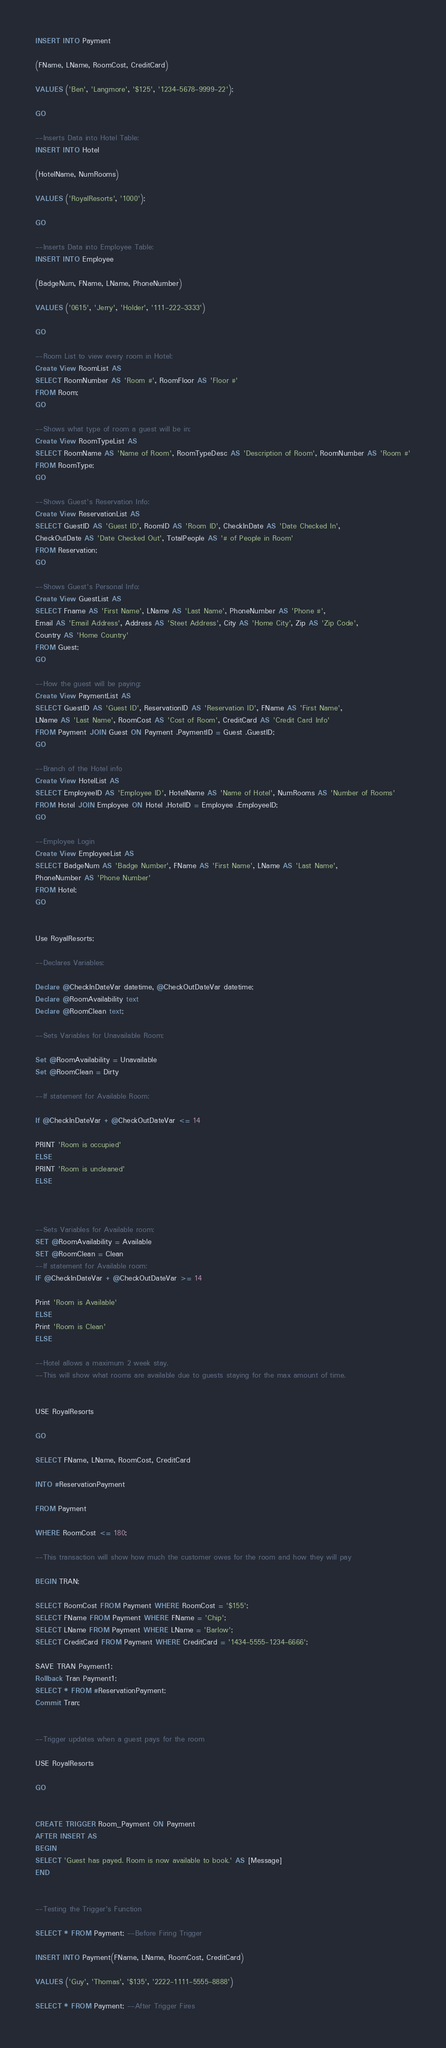Convert code to text. <code><loc_0><loc_0><loc_500><loc_500><_SQL_>INSERT INTO Payment

(FName, LName, RoomCost, CreditCard)

VALUES ('Ben', 'Langmore', '$125', '1234-5678-9999-22');

GO

--Inserts Data into Hotel Table:
INSERT INTO Hotel

(HotelName, NumRooms)

VALUES ('RoyalResorts', '1000');

GO

--Inserts Data into Employee Table:
INSERT INTO Employee

(BadgeNum, FName, LName, PhoneNumber)

VALUES ('0615', 'Jerry', 'Holder', '111-222-3333')

GO

--Room List to view every room in Hotel:
Create View RoomList AS
SELECT RoomNumber AS 'Room #', RoomFloor AS 'Floor #'
FROM Room;
GO

--Shows what type of room a guest will be in:
Create View RoomTypeList AS
SELECT RoomName AS 'Name of Room', RoomTypeDesc AS 'Description of Room', RoomNumber AS 'Room #'
FROM RoomType;
GO

--Shows Guest's Reservation Info:
Create View ReservationList AS
SELECT GuestID AS 'Guest ID', RoomID AS 'Room ID', CheckInDate AS 'Date Checked In',
CheckOutDate AS 'Date Checked Out', TotalPeople AS '# of People in Room'
FROM Reservation;
GO

--Shows Guest's Personal Info:
Create View GuestList AS
SELECT Fname AS 'First Name', LName AS 'Last Name', PhoneNumber AS 'Phone #',
Email AS 'Email Address', Address AS 'Steet Address', City AS 'Home City', Zip AS 'Zip Code',
Country AS 'Home Country'
FROM Guest;
GO

--How the guest will be paying:
Create View PaymentList AS
SELECT GuestID AS 'Guest ID', ReservationID AS 'Reservation ID', FName AS 'First Name',
LName AS 'Last Name', RoomCost AS 'Cost of Room', CreditCard AS 'Credit Card Info'
FROM Payment JOIN Guest ON Payment .PaymentID = Guest .GuestID;
GO

--Branch of the Hotel info
Create View HotelList AS
SELECT EmployeeID AS 'Employee ID', HotelName AS 'Name of Hotel', NumRooms AS 'Number of Rooms'
FROM Hotel JOIN Employee ON Hotel .HotelID = Employee .EmployeeID;
GO

--Employee Login
Create View EmployeeList AS
SELECT BadgeNum AS 'Badge Number', FName AS 'First Name', LName AS 'Last Name', 
PhoneNumber AS 'Phone Number'
FROM Hotel;
GO


Use RoyalResorts;

--Declares Variables:

Declare @CheckInDateVar datetime, @CheckOutDateVar datetime;
Declare @RoomAvailability text
Declare @RoomClean text; 

--Sets Variables for Unavailable Room:

Set @RoomAvailability = Unavailable
Set @RoomClean = Dirty

--If statement for Available Room:

If @CheckInDateVar + @CheckOutDateVar <= 14

PRINT 'Room is occupied'
ELSE
PRINT 'Room is uncleaned'
ELSE



--Sets Variables for Available room:
SET @RoomAvailability = Available
SET @RoomClean = Clean
--If statement for Available room:
IF @CheckInDateVar + @CheckOutDateVar >= 14

Print 'Room is Available'
ELSE
Print 'Room is Clean'
ELSE

--Hotel allows a maximum 2 week stay.
--This will show what rooms are available due to guests staying for the max amount of time.


USE RoyalResorts

GO

SELECT FName, LName, RoomCost, CreditCard

INTO #ReservationPayment

FROM Payment

WHERE RoomCost <= 180;

--This transaction will show how much the customer owes for the room and how they will pay

BEGIN TRAN;

SELECT RoomCost FROM Payment WHERE RoomCost = '$155';
SELECT FName FROM Payment WHERE FName = 'Chip';
SELECT LName FROM Payment WHERE LName = 'Barlow';
SELECT CreditCard FROM Payment WHERE CreditCard = '1434-5555-1234-6666';

SAVE TRAN Payment1;
Rollback Tran Payment1;
SELECT * FROM #ReservationPayment;
Commit Tran; 


--Trigger updates when a guest pays for the room

USE RoyalResorts

GO


CREATE TRIGGER Room_Payment ON Payment
AFTER INSERT AS
BEGIN
SELECT 'Guest has payed. Room is now available to book.' AS [Message]
END


--Testing the Trigger's Function

SELECT * FROM Payment; --Before Firing Trigger

INSERT INTO Payment(FName, LName, RoomCost, CreditCard)

VALUES ('Guy', 'Thomas', '$135', '2222-1111-5555-8888')

SELECT * FROM Payment; --After Trigger Fires


</code> 